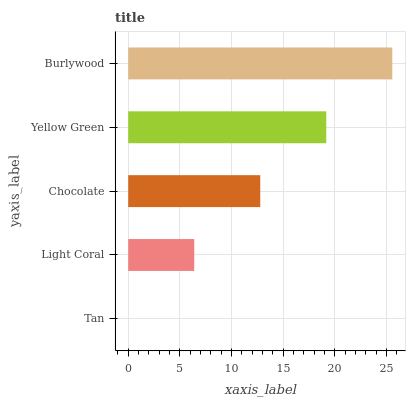Is Tan the minimum?
Answer yes or no. Yes. Is Burlywood the maximum?
Answer yes or no. Yes. Is Light Coral the minimum?
Answer yes or no. No. Is Light Coral the maximum?
Answer yes or no. No. Is Light Coral greater than Tan?
Answer yes or no. Yes. Is Tan less than Light Coral?
Answer yes or no. Yes. Is Tan greater than Light Coral?
Answer yes or no. No. Is Light Coral less than Tan?
Answer yes or no. No. Is Chocolate the high median?
Answer yes or no. Yes. Is Chocolate the low median?
Answer yes or no. Yes. Is Tan the high median?
Answer yes or no. No. Is Light Coral the low median?
Answer yes or no. No. 